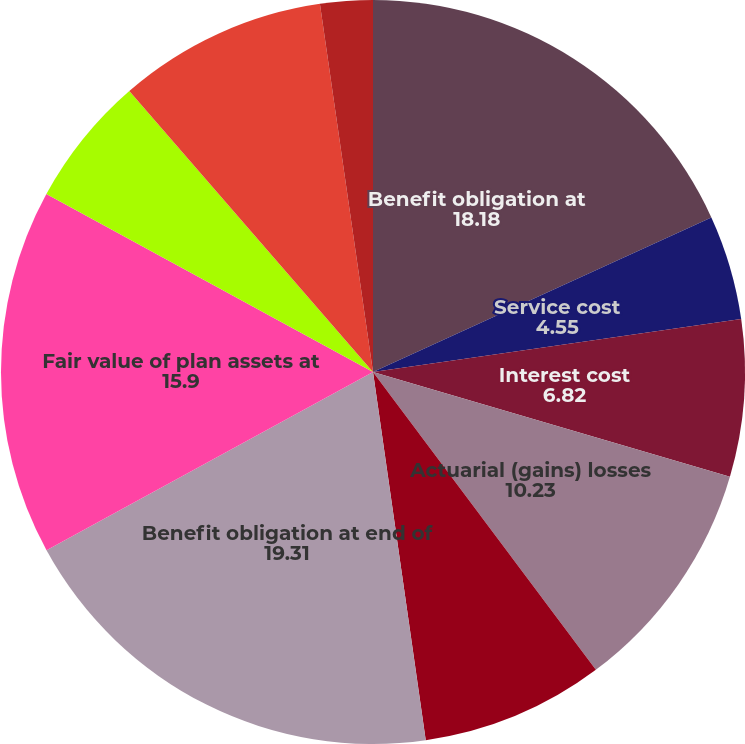Convert chart. <chart><loc_0><loc_0><loc_500><loc_500><pie_chart><fcel>Benefit obligation at<fcel>Service cost<fcel>Interest cost<fcel>Actuarial (gains) losses<fcel>Benefit payments<fcel>Benefit obligation at end of<fcel>Fair value of plan assets at<fcel>Actual return on plan assets<fcel>Employer contributions<fcel>Expenses<nl><fcel>18.18%<fcel>4.55%<fcel>6.82%<fcel>10.23%<fcel>7.96%<fcel>19.31%<fcel>15.9%<fcel>5.69%<fcel>9.09%<fcel>2.28%<nl></chart> 